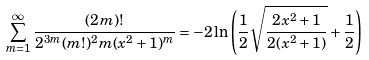<formula> <loc_0><loc_0><loc_500><loc_500>\sum _ { m = 1 } ^ { \infty } \frac { ( 2 m ) ! } { 2 ^ { 3 m } ( m ! ) ^ { 2 } m ( x ^ { 2 } + 1 ) ^ { m } } = - 2 \ln \left ( \frac { 1 } { 2 } \sqrt { \frac { 2 x ^ { 2 } + 1 } { 2 ( x ^ { 2 } + 1 ) } } + \frac { 1 } { 2 } \right )</formula> 